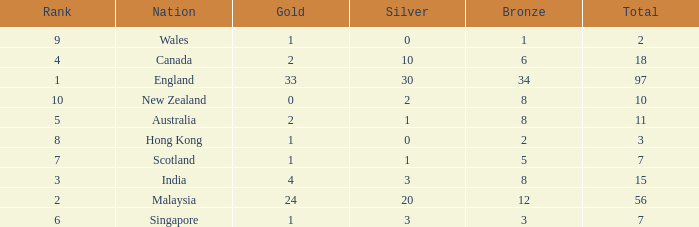What is the most gold medals a team with less than 2 silvers, more than 7 total medals, and less than 8 bronze medals has? None. 